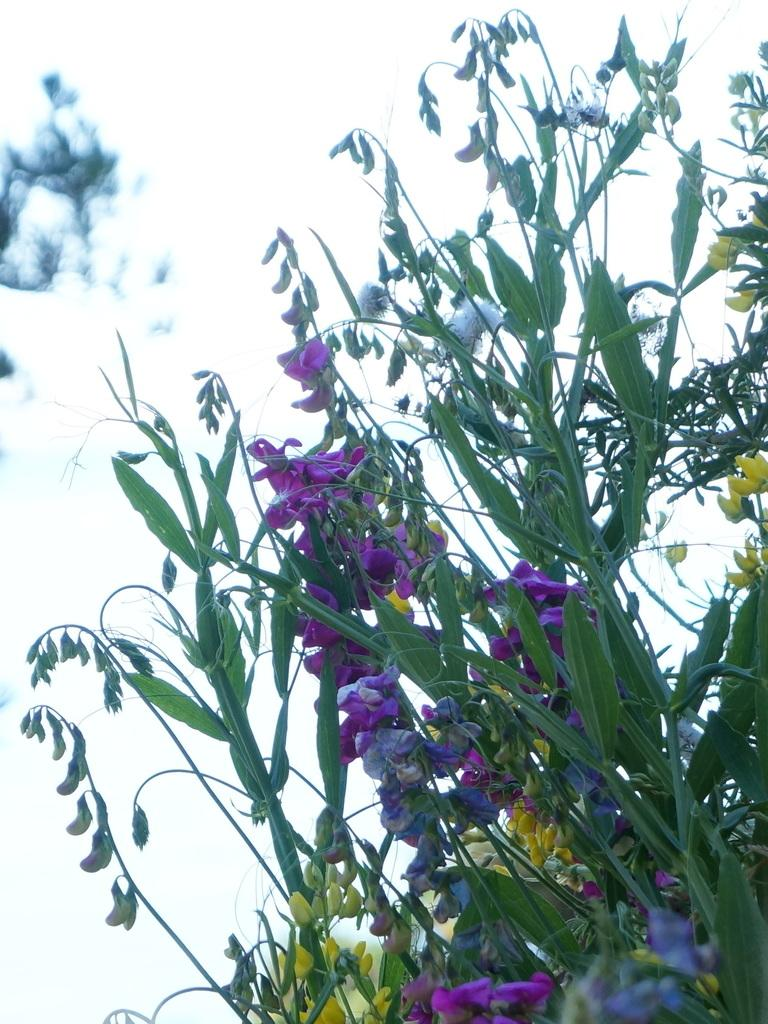What is the main subject of the image? There is a plant in the center of the image. What features can be observed on the plant? The plant has flowers, leaves, and buds. How would you describe the background of the image? The background of the image is blurry. How many legs does the plant have in the image? Plants do not have legs, so this question cannot be answered. 